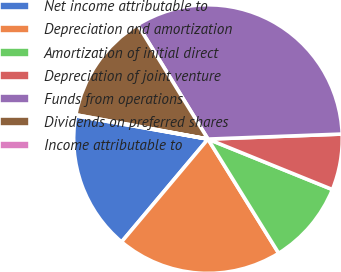Convert chart. <chart><loc_0><loc_0><loc_500><loc_500><pie_chart><fcel>Net income attributable to<fcel>Depreciation and amortization<fcel>Amortization of initial direct<fcel>Depreciation of joint venture<fcel>Funds from operations<fcel>Dividends on preferred shares<fcel>Income attributable to<nl><fcel>16.65%<fcel>19.95%<fcel>10.04%<fcel>6.73%<fcel>33.17%<fcel>13.34%<fcel>0.12%<nl></chart> 